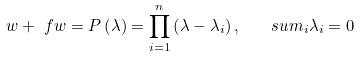Convert formula to latex. <formula><loc_0><loc_0><loc_500><loc_500>w + { \ f w } = P \left ( \lambda \right ) = \prod _ { i = 1 } ^ { n } \left ( \lambda - \lambda _ { i } \right ) , \quad s u m _ { i } \lambda _ { i } = 0</formula> 